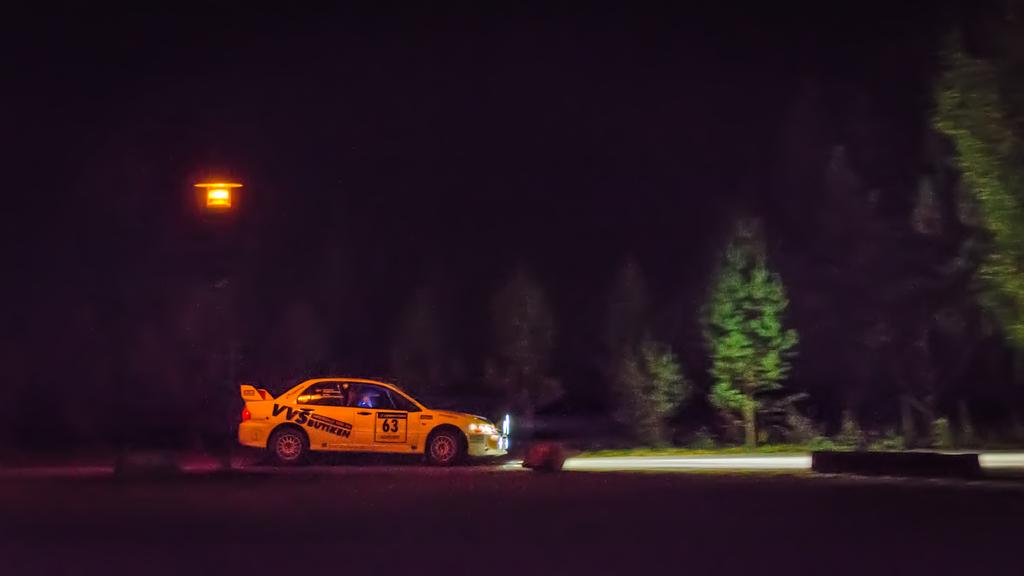What is the main subject of the image? There is a car on the road in the image. What else can be seen beside the road? There are objects beside the road. What type of natural scenery is visible in the background? There are trees in the background of the image. What can be seen in the distance in the background? There is a light in the background of the image. Can you tell me how many streams are visible in the image? There are no streams visible in the image. What type of soda is being advertised on the car in the image? There is no soda or advertisement present on the car in the image. 